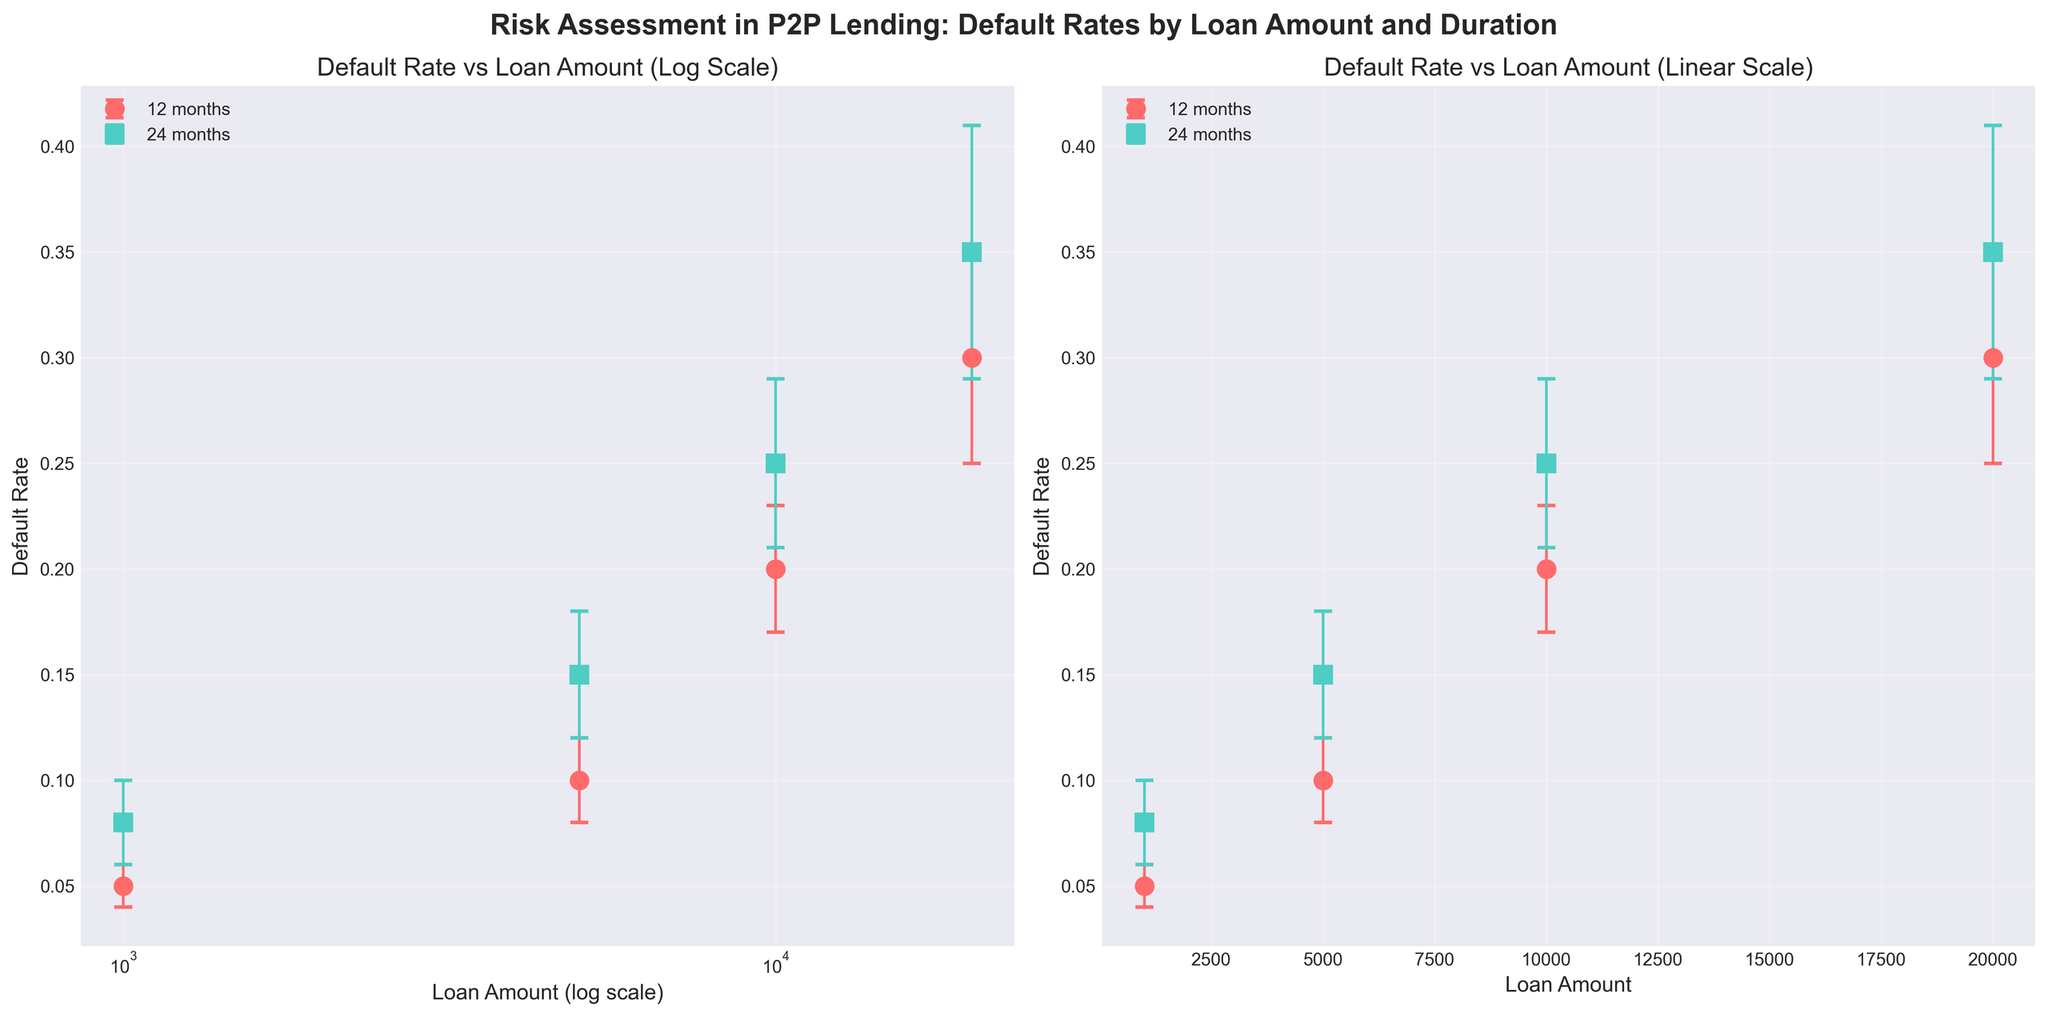What's the title of the figure? The title is displayed at the top center of the figure. It reads "Risk Assessment in P2P Lending: Default Rates by Loan Amount and Duration".
Answer: Risk Assessment in P2P Lending: Default Rates by Loan Amount and Duration How many subplots are in the figure? There are two subplots in the figure, which are evident from the side-by-side layout of the two charts.
Answer: Two What variables are plotted on the x-axis and y-axis in both subplots? In both subplots, the x-axis represents 'Loan Amount' while the y-axis represents 'Default Rate'. This is clearly labeled on both axes in each subplot.
Answer: Loan Amount (x-axis), Default Rate (y-axis) What's the highest default rate shown for a 12-month duration? To find this, look for the highest point or bar labeled as '12 months' in the legend. In this case, the highest default rate for 12 months appears at a loan amount of 20000, which is 0.30.
Answer: 0.30 How does the scale of the x-axis differ between the two subplots? The left subplot has a log scale on the x-axis (labeled as 'Loan Amount (log scale)'), while the right subplot uses a linear scale. This difference is indicated clearly on the x-axis labels.
Answer: Log scale (left), Linear scale (right) Which loan amount and duration combination has the highest error bar? To determine this, look at the length of the error bars across all points. The longest error bar belongs to the combination of 20000 loan amount and 24 months duration, with an error of 0.06.
Answer: 20000 loan amount and 24 months duration Compare the default rates for a loan amount of 10000 across both durations. For a loan amount of 10000, the default rates for 12 months and 24 months can be compared. The point markers indicate these rates: 0.20 for 12 months and 0.25 for 24 months. Hence, the default rate is higher for a 24-month duration.
Answer: Higher for 24 months What's the difference in default rate between the 12-month and 24-month durations for a loan amount of 5000? Identify the default rates for both durations at 5000 loan amount. These are 0.10 (12 months) and 0.15 (24 months). The difference is 0.15 - 0.10.
Answer: 0.05 Are there any loan amounts where the default rates are the same across different durations? Compare default rates across different durations for each loan amount. None of the plotted loan amounts have the same default rates for both durations.
Answer: No What are the color and shape of the markers used to represent data for a 24-month duration? The markers and colors are labeled in the legend. For the 24-month duration, markers are square-shaped ('s') and in a repeating color-coded sequence which is teal in this figure.
Answer: Square, Teal 